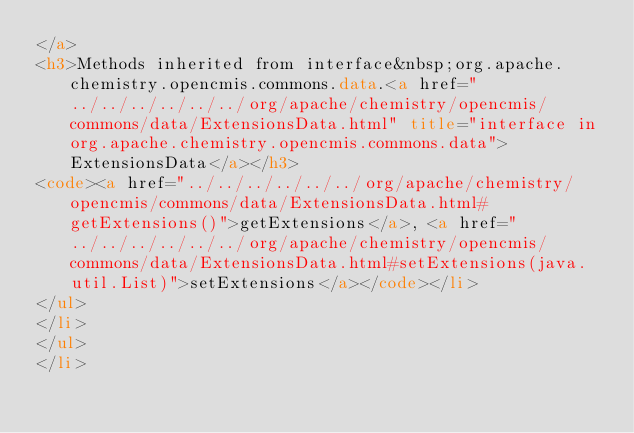Convert code to text. <code><loc_0><loc_0><loc_500><loc_500><_HTML_></a>
<h3>Methods inherited from interface&nbsp;org.apache.chemistry.opencmis.commons.data.<a href="../../../../../../org/apache/chemistry/opencmis/commons/data/ExtensionsData.html" title="interface in org.apache.chemistry.opencmis.commons.data">ExtensionsData</a></h3>
<code><a href="../../../../../../org/apache/chemistry/opencmis/commons/data/ExtensionsData.html#getExtensions()">getExtensions</a>, <a href="../../../../../../org/apache/chemistry/opencmis/commons/data/ExtensionsData.html#setExtensions(java.util.List)">setExtensions</a></code></li>
</ul>
</li>
</ul>
</li></code> 